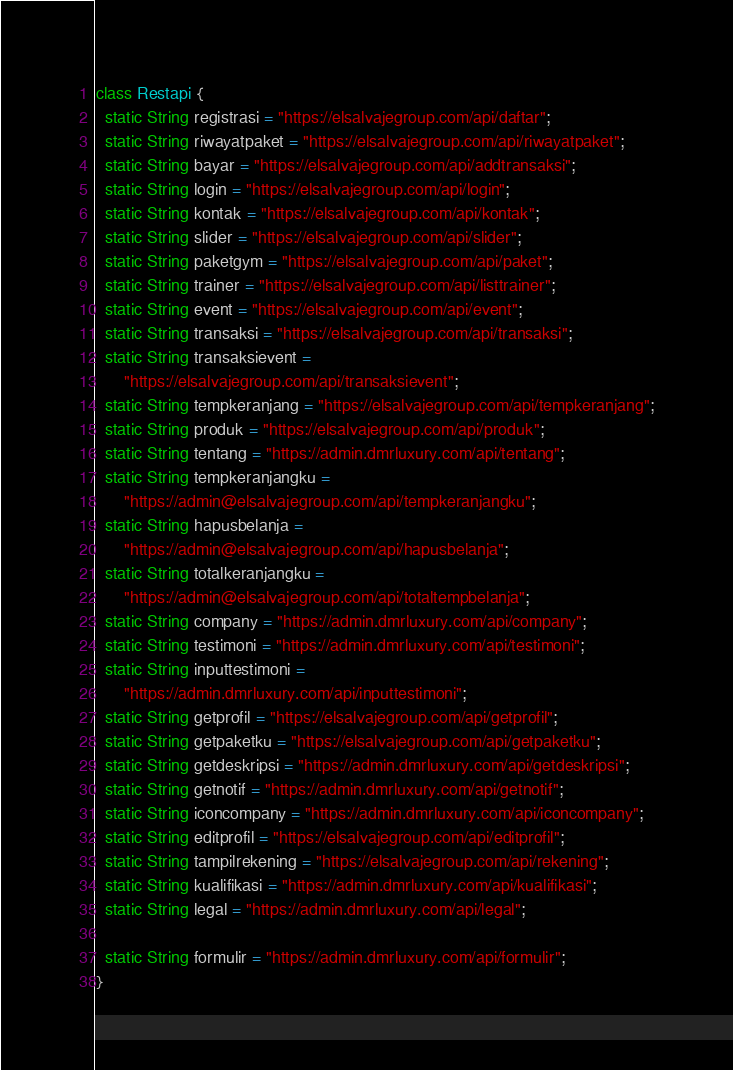Convert code to text. <code><loc_0><loc_0><loc_500><loc_500><_Dart_>class Restapi {
  static String registrasi = "https://elsalvajegroup.com/api/daftar";
  static String riwayatpaket = "https://elsalvajegroup.com/api/riwayatpaket";
  static String bayar = "https://elsalvajegroup.com/api/addtransaksi";
  static String login = "https://elsalvajegroup.com/api/login";
  static String kontak = "https://elsalvajegroup.com/api/kontak";
  static String slider = "https://elsalvajegroup.com/api/slider";
  static String paketgym = "https://elsalvajegroup.com/api/paket";
  static String trainer = "https://elsalvajegroup.com/api/listtrainer";
  static String event = "https://elsalvajegroup.com/api/event";
  static String transaksi = "https://elsalvajegroup.com/api/transaksi";
  static String transaksievent =
      "https://elsalvajegroup.com/api/transaksievent";
  static String tempkeranjang = "https://elsalvajegroup.com/api/tempkeranjang";
  static String produk = "https://elsalvajegroup.com/api/produk";
  static String tentang = "https://admin.dmrluxury.com/api/tentang";
  static String tempkeranjangku =
      "https://admin@elsalvajegroup.com/api/tempkeranjangku";
  static String hapusbelanja =
      "https://admin@elsalvajegroup.com/api/hapusbelanja";
  static String totalkeranjangku =
      "https://admin@elsalvajegroup.com/api/totaltempbelanja";
  static String company = "https://admin.dmrluxury.com/api/company";
  static String testimoni = "https://admin.dmrluxury.com/api/testimoni";
  static String inputtestimoni =
      "https://admin.dmrluxury.com/api/inputtestimoni";
  static String getprofil = "https://elsalvajegroup.com/api/getprofil";
  static String getpaketku = "https://elsalvajegroup.com/api/getpaketku";
  static String getdeskripsi = "https://admin.dmrluxury.com/api/getdeskripsi";
  static String getnotif = "https://admin.dmrluxury.com/api/getnotif";
  static String iconcompany = "https://admin.dmrluxury.com/api/iconcompany";
  static String editprofil = "https://elsalvajegroup.com/api/editprofil";
  static String tampilrekening = "https://elsalvajegroup.com/api/rekening";
  static String kualifikasi = "https://admin.dmrluxury.com/api/kualifikasi";
  static String legal = "https://admin.dmrluxury.com/api/legal";

  static String formulir = "https://admin.dmrluxury.com/api/formulir";
}
</code> 